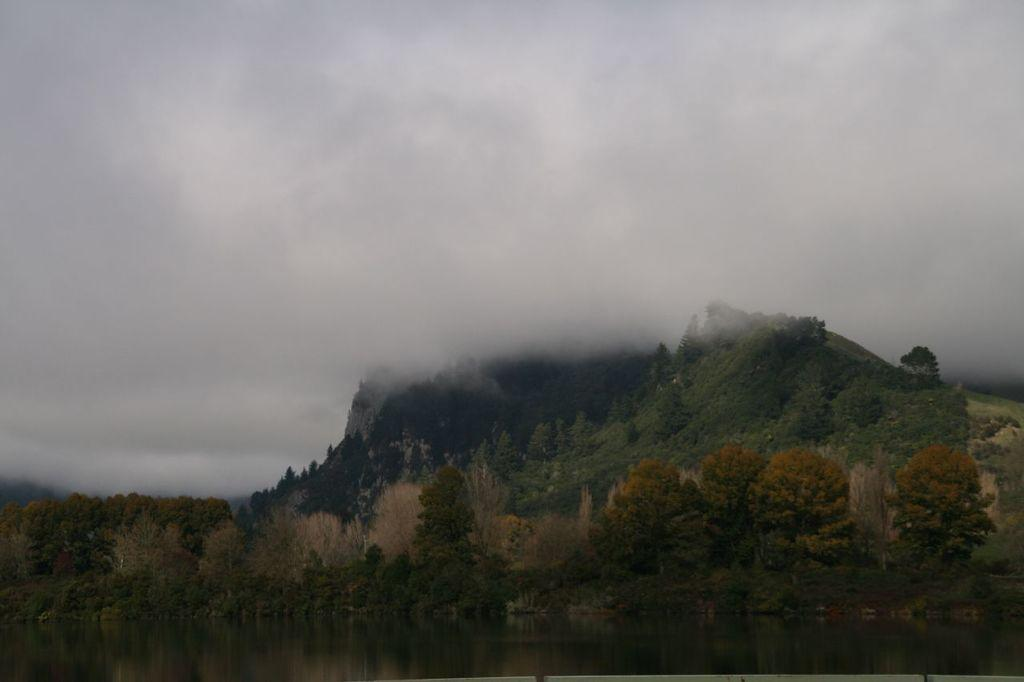What natural element can be seen in the image? Water is visible in the image. What type of vegetation is present in the image? There are trees in the image. What geographical feature can be seen in the image? There are mountains in the image. What is visible at the top of the image? The sky is visible in the image. Can you tell me how many kittens are playing with a club in the image? There are no kittens or clubs present in the image, and therefore no such activity can be observed. What part of the mountains is visible in the image? The image shows the mountains as a whole, not just a part of them. 